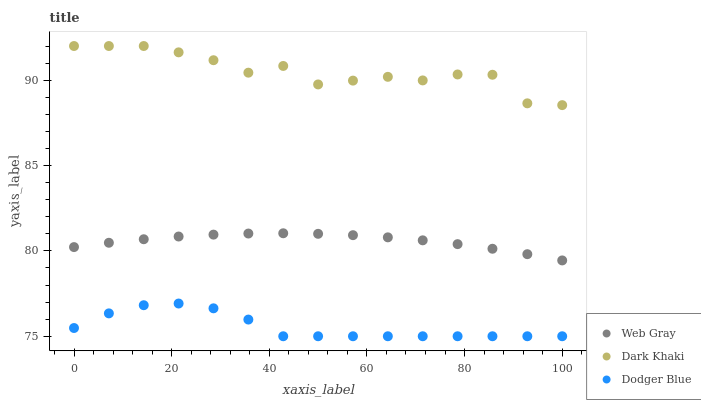Does Dodger Blue have the minimum area under the curve?
Answer yes or no. Yes. Does Dark Khaki have the maximum area under the curve?
Answer yes or no. Yes. Does Web Gray have the minimum area under the curve?
Answer yes or no. No. Does Web Gray have the maximum area under the curve?
Answer yes or no. No. Is Web Gray the smoothest?
Answer yes or no. Yes. Is Dark Khaki the roughest?
Answer yes or no. Yes. Is Dodger Blue the smoothest?
Answer yes or no. No. Is Dodger Blue the roughest?
Answer yes or no. No. Does Dodger Blue have the lowest value?
Answer yes or no. Yes. Does Web Gray have the lowest value?
Answer yes or no. No. Does Dark Khaki have the highest value?
Answer yes or no. Yes. Does Web Gray have the highest value?
Answer yes or no. No. Is Dodger Blue less than Dark Khaki?
Answer yes or no. Yes. Is Dark Khaki greater than Web Gray?
Answer yes or no. Yes. Does Dodger Blue intersect Dark Khaki?
Answer yes or no. No. 